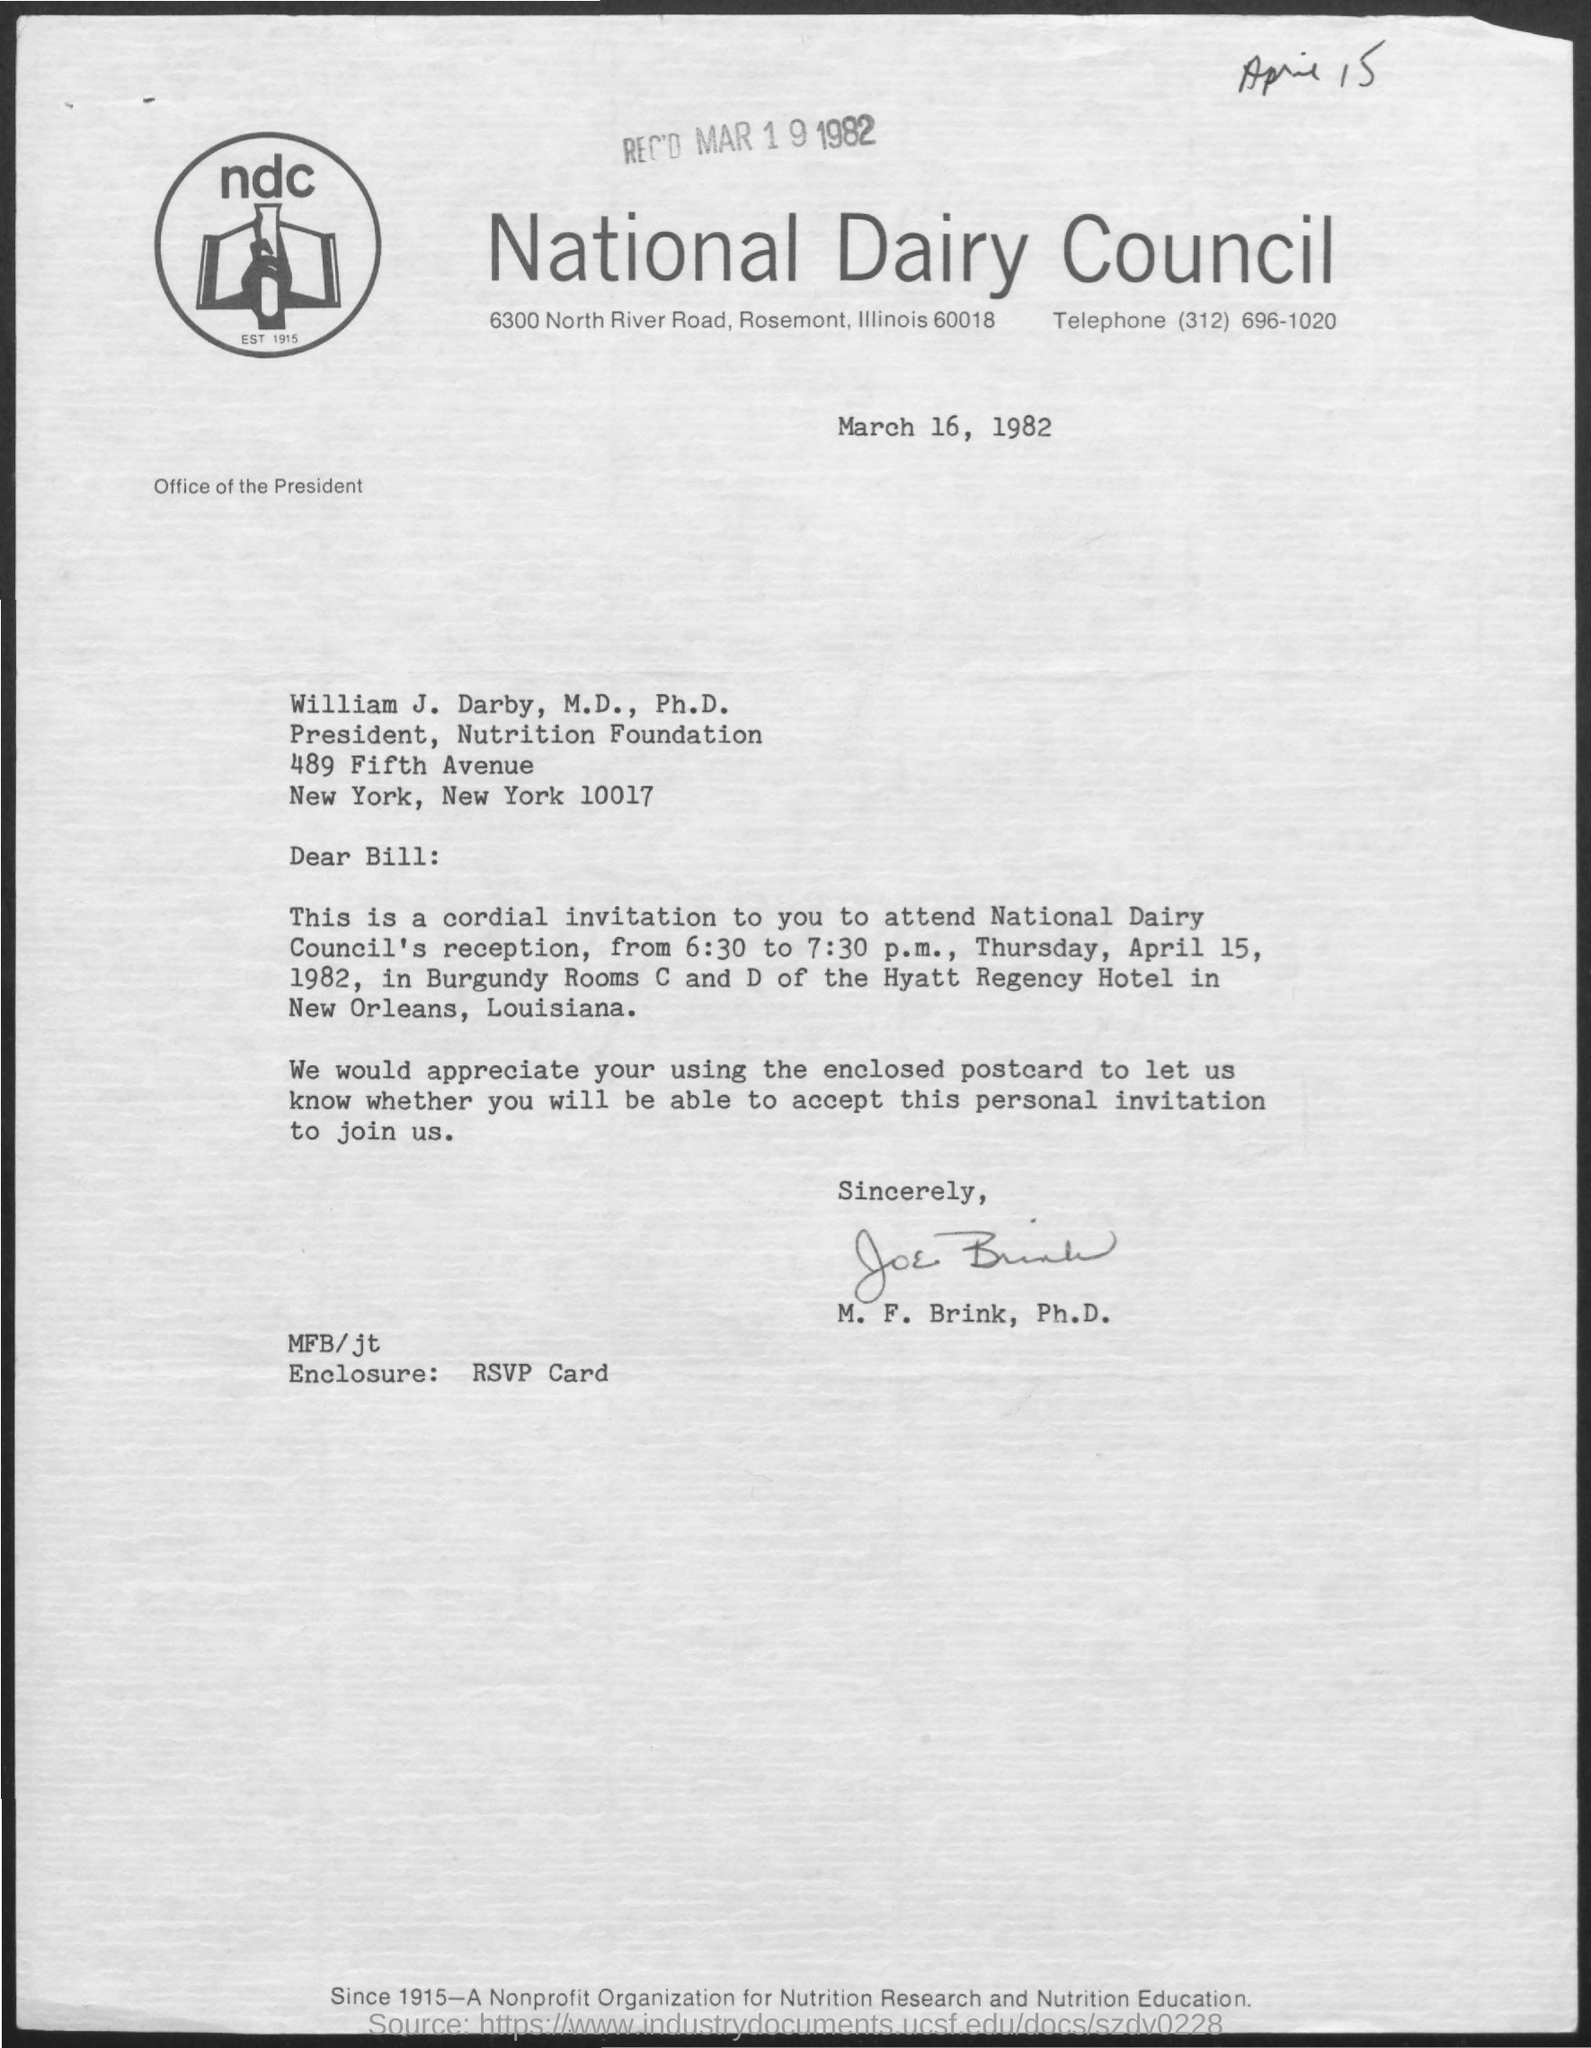List a handful of essential elements in this visual. The telephone number provided is (312) 696-1020. The National Dairy Council's reception is to be held on April 15, 1982. The document is dated March 16, 1982. What is the enclosure? Please respond with an RSVP card. The sender is Joe Brink. 